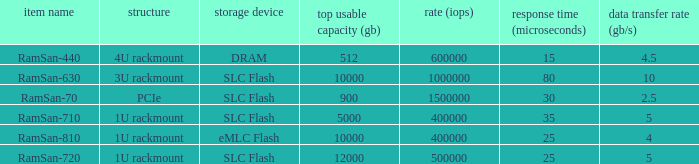What is the ramsan-810 transfer delay? 1.0. 